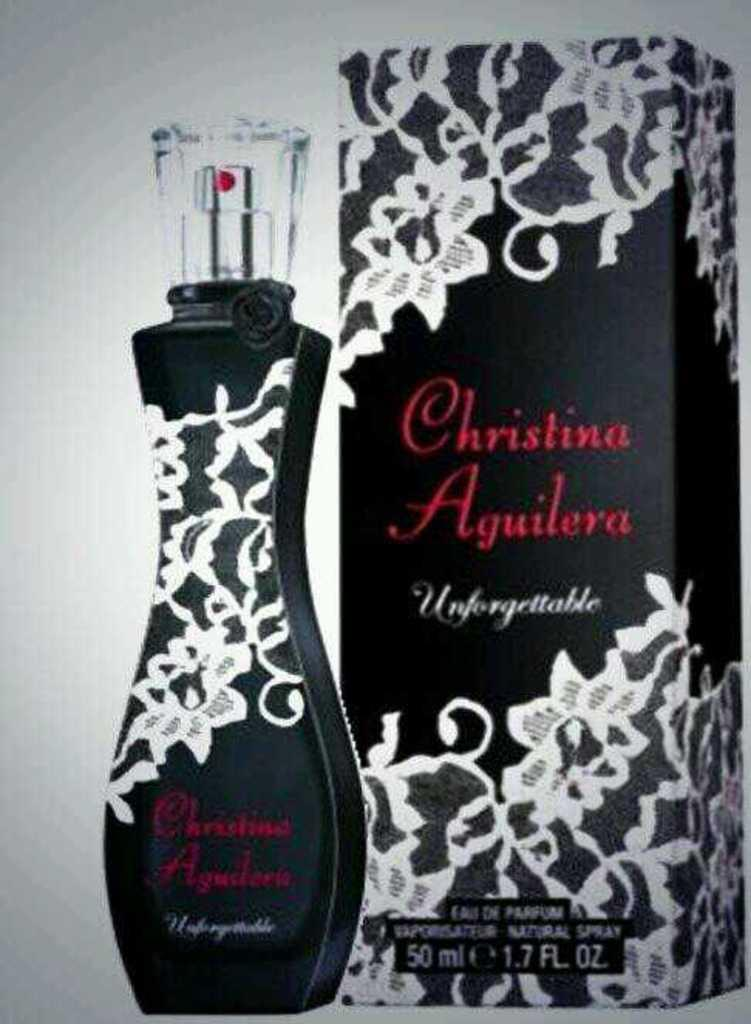<image>
Describe the image concisely. Christina Aguilera perfume standing next to same box 